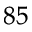<formula> <loc_0><loc_0><loc_500><loc_500>^ { 8 5 }</formula> 